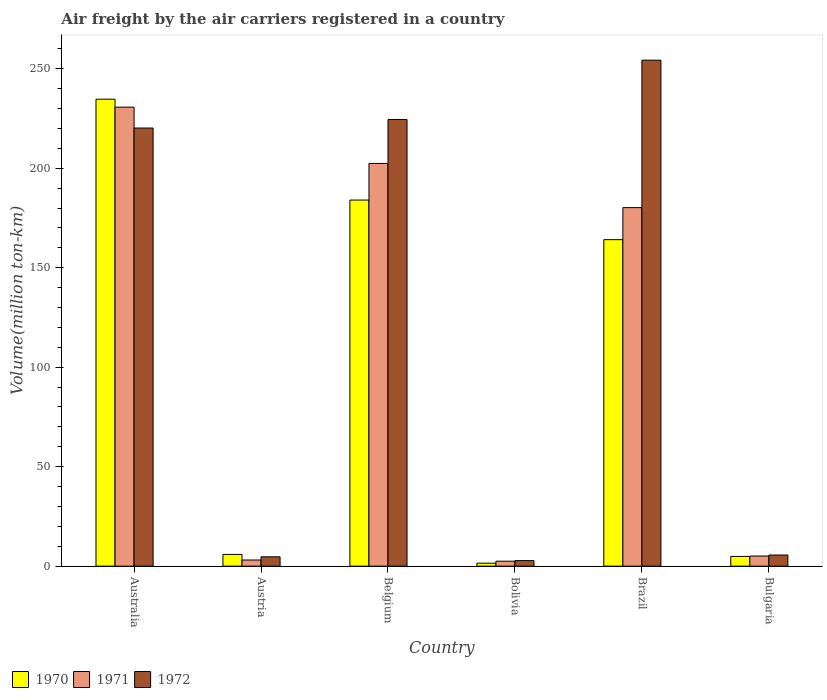How many different coloured bars are there?
Your answer should be compact. 3. How many groups of bars are there?
Provide a short and direct response. 6. Are the number of bars on each tick of the X-axis equal?
Your response must be concise. Yes. How many bars are there on the 4th tick from the right?
Offer a very short reply. 3. In how many cases, is the number of bars for a given country not equal to the number of legend labels?
Your response must be concise. 0. What is the volume of the air carriers in 1971 in Belgium?
Offer a very short reply. 202.4. Across all countries, what is the maximum volume of the air carriers in 1971?
Your answer should be very brief. 230.7. Across all countries, what is the minimum volume of the air carriers in 1970?
Provide a succinct answer. 1.5. In which country was the volume of the air carriers in 1970 maximum?
Your answer should be compact. Australia. What is the total volume of the air carriers in 1972 in the graph?
Offer a very short reply. 712.1. What is the difference between the volume of the air carriers in 1970 in Belgium and that in Bulgaria?
Provide a succinct answer. 179.1. What is the difference between the volume of the air carriers in 1970 in Austria and the volume of the air carriers in 1972 in Bulgaria?
Keep it short and to the point. 0.3. What is the average volume of the air carriers in 1971 per country?
Your answer should be very brief. 104. What is the difference between the volume of the air carriers of/in 1972 and volume of the air carriers of/in 1970 in Bolivia?
Offer a very short reply. 1.3. What is the ratio of the volume of the air carriers in 1971 in Bolivia to that in Brazil?
Provide a short and direct response. 0.01. Is the volume of the air carriers in 1971 in Belgium less than that in Bolivia?
Your answer should be very brief. No. What is the difference between the highest and the second highest volume of the air carriers in 1970?
Your response must be concise. -50.7. What is the difference between the highest and the lowest volume of the air carriers in 1970?
Ensure brevity in your answer.  233.2. Is it the case that in every country, the sum of the volume of the air carriers in 1970 and volume of the air carriers in 1972 is greater than the volume of the air carriers in 1971?
Provide a short and direct response. Yes. How many bars are there?
Your answer should be very brief. 18. Are all the bars in the graph horizontal?
Your answer should be very brief. No. How many countries are there in the graph?
Ensure brevity in your answer.  6. Are the values on the major ticks of Y-axis written in scientific E-notation?
Your response must be concise. No. Where does the legend appear in the graph?
Ensure brevity in your answer.  Bottom left. How many legend labels are there?
Your response must be concise. 3. How are the legend labels stacked?
Give a very brief answer. Horizontal. What is the title of the graph?
Provide a short and direct response. Air freight by the air carriers registered in a country. Does "1965" appear as one of the legend labels in the graph?
Ensure brevity in your answer.  No. What is the label or title of the Y-axis?
Offer a very short reply. Volume(million ton-km). What is the Volume(million ton-km) in 1970 in Australia?
Provide a short and direct response. 234.7. What is the Volume(million ton-km) of 1971 in Australia?
Offer a terse response. 230.7. What is the Volume(million ton-km) in 1972 in Australia?
Provide a short and direct response. 220.2. What is the Volume(million ton-km) of 1970 in Austria?
Give a very brief answer. 5.9. What is the Volume(million ton-km) of 1971 in Austria?
Your response must be concise. 3.1. What is the Volume(million ton-km) in 1972 in Austria?
Ensure brevity in your answer.  4.7. What is the Volume(million ton-km) in 1970 in Belgium?
Your answer should be compact. 184. What is the Volume(million ton-km) in 1971 in Belgium?
Your response must be concise. 202.4. What is the Volume(million ton-km) in 1972 in Belgium?
Provide a short and direct response. 224.5. What is the Volume(million ton-km) of 1971 in Bolivia?
Ensure brevity in your answer.  2.5. What is the Volume(million ton-km) of 1972 in Bolivia?
Provide a succinct answer. 2.8. What is the Volume(million ton-km) in 1970 in Brazil?
Ensure brevity in your answer.  164.1. What is the Volume(million ton-km) of 1971 in Brazil?
Offer a terse response. 180.2. What is the Volume(million ton-km) of 1972 in Brazil?
Offer a terse response. 254.3. What is the Volume(million ton-km) of 1970 in Bulgaria?
Offer a terse response. 4.9. What is the Volume(million ton-km) of 1971 in Bulgaria?
Your answer should be compact. 5.1. What is the Volume(million ton-km) in 1972 in Bulgaria?
Give a very brief answer. 5.6. Across all countries, what is the maximum Volume(million ton-km) in 1970?
Make the answer very short. 234.7. Across all countries, what is the maximum Volume(million ton-km) of 1971?
Your answer should be very brief. 230.7. Across all countries, what is the maximum Volume(million ton-km) of 1972?
Your answer should be very brief. 254.3. Across all countries, what is the minimum Volume(million ton-km) in 1972?
Make the answer very short. 2.8. What is the total Volume(million ton-km) in 1970 in the graph?
Offer a terse response. 595.1. What is the total Volume(million ton-km) in 1971 in the graph?
Your answer should be very brief. 624. What is the total Volume(million ton-km) of 1972 in the graph?
Provide a short and direct response. 712.1. What is the difference between the Volume(million ton-km) in 1970 in Australia and that in Austria?
Your answer should be very brief. 228.8. What is the difference between the Volume(million ton-km) of 1971 in Australia and that in Austria?
Provide a succinct answer. 227.6. What is the difference between the Volume(million ton-km) of 1972 in Australia and that in Austria?
Provide a short and direct response. 215.5. What is the difference between the Volume(million ton-km) of 1970 in Australia and that in Belgium?
Ensure brevity in your answer.  50.7. What is the difference between the Volume(million ton-km) in 1971 in Australia and that in Belgium?
Give a very brief answer. 28.3. What is the difference between the Volume(million ton-km) in 1970 in Australia and that in Bolivia?
Give a very brief answer. 233.2. What is the difference between the Volume(million ton-km) of 1971 in Australia and that in Bolivia?
Provide a short and direct response. 228.2. What is the difference between the Volume(million ton-km) of 1972 in Australia and that in Bolivia?
Provide a short and direct response. 217.4. What is the difference between the Volume(million ton-km) in 1970 in Australia and that in Brazil?
Keep it short and to the point. 70.6. What is the difference between the Volume(million ton-km) of 1971 in Australia and that in Brazil?
Your answer should be very brief. 50.5. What is the difference between the Volume(million ton-km) in 1972 in Australia and that in Brazil?
Provide a short and direct response. -34.1. What is the difference between the Volume(million ton-km) of 1970 in Australia and that in Bulgaria?
Offer a terse response. 229.8. What is the difference between the Volume(million ton-km) of 1971 in Australia and that in Bulgaria?
Provide a short and direct response. 225.6. What is the difference between the Volume(million ton-km) in 1972 in Australia and that in Bulgaria?
Make the answer very short. 214.6. What is the difference between the Volume(million ton-km) of 1970 in Austria and that in Belgium?
Your answer should be very brief. -178.1. What is the difference between the Volume(million ton-km) in 1971 in Austria and that in Belgium?
Offer a terse response. -199.3. What is the difference between the Volume(million ton-km) of 1972 in Austria and that in Belgium?
Offer a very short reply. -219.8. What is the difference between the Volume(million ton-km) in 1970 in Austria and that in Bolivia?
Keep it short and to the point. 4.4. What is the difference between the Volume(million ton-km) in 1971 in Austria and that in Bolivia?
Provide a succinct answer. 0.6. What is the difference between the Volume(million ton-km) of 1970 in Austria and that in Brazil?
Provide a succinct answer. -158.2. What is the difference between the Volume(million ton-km) of 1971 in Austria and that in Brazil?
Offer a very short reply. -177.1. What is the difference between the Volume(million ton-km) of 1972 in Austria and that in Brazil?
Your answer should be very brief. -249.6. What is the difference between the Volume(million ton-km) in 1971 in Austria and that in Bulgaria?
Provide a short and direct response. -2. What is the difference between the Volume(million ton-km) in 1970 in Belgium and that in Bolivia?
Your answer should be compact. 182.5. What is the difference between the Volume(million ton-km) of 1971 in Belgium and that in Bolivia?
Keep it short and to the point. 199.9. What is the difference between the Volume(million ton-km) of 1972 in Belgium and that in Bolivia?
Provide a succinct answer. 221.7. What is the difference between the Volume(million ton-km) in 1971 in Belgium and that in Brazil?
Your response must be concise. 22.2. What is the difference between the Volume(million ton-km) of 1972 in Belgium and that in Brazil?
Your response must be concise. -29.8. What is the difference between the Volume(million ton-km) of 1970 in Belgium and that in Bulgaria?
Keep it short and to the point. 179.1. What is the difference between the Volume(million ton-km) of 1971 in Belgium and that in Bulgaria?
Keep it short and to the point. 197.3. What is the difference between the Volume(million ton-km) of 1972 in Belgium and that in Bulgaria?
Your answer should be compact. 218.9. What is the difference between the Volume(million ton-km) in 1970 in Bolivia and that in Brazil?
Give a very brief answer. -162.6. What is the difference between the Volume(million ton-km) in 1971 in Bolivia and that in Brazil?
Offer a terse response. -177.7. What is the difference between the Volume(million ton-km) in 1972 in Bolivia and that in Brazil?
Your answer should be compact. -251.5. What is the difference between the Volume(million ton-km) in 1970 in Bolivia and that in Bulgaria?
Your response must be concise. -3.4. What is the difference between the Volume(million ton-km) in 1970 in Brazil and that in Bulgaria?
Offer a terse response. 159.2. What is the difference between the Volume(million ton-km) in 1971 in Brazil and that in Bulgaria?
Offer a very short reply. 175.1. What is the difference between the Volume(million ton-km) of 1972 in Brazil and that in Bulgaria?
Provide a succinct answer. 248.7. What is the difference between the Volume(million ton-km) of 1970 in Australia and the Volume(million ton-km) of 1971 in Austria?
Provide a succinct answer. 231.6. What is the difference between the Volume(million ton-km) of 1970 in Australia and the Volume(million ton-km) of 1972 in Austria?
Your answer should be very brief. 230. What is the difference between the Volume(million ton-km) of 1971 in Australia and the Volume(million ton-km) of 1972 in Austria?
Your answer should be compact. 226. What is the difference between the Volume(million ton-km) in 1970 in Australia and the Volume(million ton-km) in 1971 in Belgium?
Keep it short and to the point. 32.3. What is the difference between the Volume(million ton-km) of 1970 in Australia and the Volume(million ton-km) of 1971 in Bolivia?
Make the answer very short. 232.2. What is the difference between the Volume(million ton-km) of 1970 in Australia and the Volume(million ton-km) of 1972 in Bolivia?
Keep it short and to the point. 231.9. What is the difference between the Volume(million ton-km) in 1971 in Australia and the Volume(million ton-km) in 1972 in Bolivia?
Give a very brief answer. 227.9. What is the difference between the Volume(million ton-km) in 1970 in Australia and the Volume(million ton-km) in 1971 in Brazil?
Your answer should be compact. 54.5. What is the difference between the Volume(million ton-km) of 1970 in Australia and the Volume(million ton-km) of 1972 in Brazil?
Your answer should be very brief. -19.6. What is the difference between the Volume(million ton-km) of 1971 in Australia and the Volume(million ton-km) of 1972 in Brazil?
Keep it short and to the point. -23.6. What is the difference between the Volume(million ton-km) of 1970 in Australia and the Volume(million ton-km) of 1971 in Bulgaria?
Keep it short and to the point. 229.6. What is the difference between the Volume(million ton-km) in 1970 in Australia and the Volume(million ton-km) in 1972 in Bulgaria?
Keep it short and to the point. 229.1. What is the difference between the Volume(million ton-km) of 1971 in Australia and the Volume(million ton-km) of 1972 in Bulgaria?
Give a very brief answer. 225.1. What is the difference between the Volume(million ton-km) of 1970 in Austria and the Volume(million ton-km) of 1971 in Belgium?
Make the answer very short. -196.5. What is the difference between the Volume(million ton-km) of 1970 in Austria and the Volume(million ton-km) of 1972 in Belgium?
Make the answer very short. -218.6. What is the difference between the Volume(million ton-km) of 1971 in Austria and the Volume(million ton-km) of 1972 in Belgium?
Give a very brief answer. -221.4. What is the difference between the Volume(million ton-km) in 1970 in Austria and the Volume(million ton-km) in 1971 in Bolivia?
Your response must be concise. 3.4. What is the difference between the Volume(million ton-km) of 1970 in Austria and the Volume(million ton-km) of 1972 in Bolivia?
Provide a short and direct response. 3.1. What is the difference between the Volume(million ton-km) in 1970 in Austria and the Volume(million ton-km) in 1971 in Brazil?
Your answer should be compact. -174.3. What is the difference between the Volume(million ton-km) in 1970 in Austria and the Volume(million ton-km) in 1972 in Brazil?
Provide a succinct answer. -248.4. What is the difference between the Volume(million ton-km) of 1971 in Austria and the Volume(million ton-km) of 1972 in Brazil?
Give a very brief answer. -251.2. What is the difference between the Volume(million ton-km) in 1970 in Austria and the Volume(million ton-km) in 1972 in Bulgaria?
Offer a very short reply. 0.3. What is the difference between the Volume(million ton-km) in 1970 in Belgium and the Volume(million ton-km) in 1971 in Bolivia?
Make the answer very short. 181.5. What is the difference between the Volume(million ton-km) of 1970 in Belgium and the Volume(million ton-km) of 1972 in Bolivia?
Keep it short and to the point. 181.2. What is the difference between the Volume(million ton-km) of 1971 in Belgium and the Volume(million ton-km) of 1972 in Bolivia?
Your answer should be compact. 199.6. What is the difference between the Volume(million ton-km) in 1970 in Belgium and the Volume(million ton-km) in 1971 in Brazil?
Keep it short and to the point. 3.8. What is the difference between the Volume(million ton-km) of 1970 in Belgium and the Volume(million ton-km) of 1972 in Brazil?
Give a very brief answer. -70.3. What is the difference between the Volume(million ton-km) in 1971 in Belgium and the Volume(million ton-km) in 1972 in Brazil?
Ensure brevity in your answer.  -51.9. What is the difference between the Volume(million ton-km) of 1970 in Belgium and the Volume(million ton-km) of 1971 in Bulgaria?
Your answer should be compact. 178.9. What is the difference between the Volume(million ton-km) in 1970 in Belgium and the Volume(million ton-km) in 1972 in Bulgaria?
Keep it short and to the point. 178.4. What is the difference between the Volume(million ton-km) in 1971 in Belgium and the Volume(million ton-km) in 1972 in Bulgaria?
Provide a short and direct response. 196.8. What is the difference between the Volume(million ton-km) of 1970 in Bolivia and the Volume(million ton-km) of 1971 in Brazil?
Your answer should be compact. -178.7. What is the difference between the Volume(million ton-km) in 1970 in Bolivia and the Volume(million ton-km) in 1972 in Brazil?
Offer a terse response. -252.8. What is the difference between the Volume(million ton-km) in 1971 in Bolivia and the Volume(million ton-km) in 1972 in Brazil?
Provide a succinct answer. -251.8. What is the difference between the Volume(million ton-km) in 1970 in Bolivia and the Volume(million ton-km) in 1971 in Bulgaria?
Offer a terse response. -3.6. What is the difference between the Volume(million ton-km) in 1971 in Bolivia and the Volume(million ton-km) in 1972 in Bulgaria?
Make the answer very short. -3.1. What is the difference between the Volume(million ton-km) of 1970 in Brazil and the Volume(million ton-km) of 1971 in Bulgaria?
Give a very brief answer. 159. What is the difference between the Volume(million ton-km) in 1970 in Brazil and the Volume(million ton-km) in 1972 in Bulgaria?
Keep it short and to the point. 158.5. What is the difference between the Volume(million ton-km) of 1971 in Brazil and the Volume(million ton-km) of 1972 in Bulgaria?
Ensure brevity in your answer.  174.6. What is the average Volume(million ton-km) of 1970 per country?
Provide a succinct answer. 99.18. What is the average Volume(million ton-km) in 1971 per country?
Your response must be concise. 104. What is the average Volume(million ton-km) in 1972 per country?
Make the answer very short. 118.68. What is the difference between the Volume(million ton-km) in 1971 and Volume(million ton-km) in 1972 in Australia?
Your answer should be compact. 10.5. What is the difference between the Volume(million ton-km) of 1970 and Volume(million ton-km) of 1971 in Austria?
Give a very brief answer. 2.8. What is the difference between the Volume(million ton-km) of 1970 and Volume(million ton-km) of 1971 in Belgium?
Keep it short and to the point. -18.4. What is the difference between the Volume(million ton-km) of 1970 and Volume(million ton-km) of 1972 in Belgium?
Your answer should be very brief. -40.5. What is the difference between the Volume(million ton-km) of 1971 and Volume(million ton-km) of 1972 in Belgium?
Give a very brief answer. -22.1. What is the difference between the Volume(million ton-km) of 1971 and Volume(million ton-km) of 1972 in Bolivia?
Provide a succinct answer. -0.3. What is the difference between the Volume(million ton-km) in 1970 and Volume(million ton-km) in 1971 in Brazil?
Your answer should be very brief. -16.1. What is the difference between the Volume(million ton-km) in 1970 and Volume(million ton-km) in 1972 in Brazil?
Ensure brevity in your answer.  -90.2. What is the difference between the Volume(million ton-km) of 1971 and Volume(million ton-km) of 1972 in Brazil?
Offer a terse response. -74.1. What is the difference between the Volume(million ton-km) of 1970 and Volume(million ton-km) of 1972 in Bulgaria?
Your answer should be compact. -0.7. What is the difference between the Volume(million ton-km) of 1971 and Volume(million ton-km) of 1972 in Bulgaria?
Make the answer very short. -0.5. What is the ratio of the Volume(million ton-km) of 1970 in Australia to that in Austria?
Give a very brief answer. 39.78. What is the ratio of the Volume(million ton-km) of 1971 in Australia to that in Austria?
Provide a succinct answer. 74.42. What is the ratio of the Volume(million ton-km) of 1972 in Australia to that in Austria?
Offer a terse response. 46.85. What is the ratio of the Volume(million ton-km) in 1970 in Australia to that in Belgium?
Provide a short and direct response. 1.28. What is the ratio of the Volume(million ton-km) of 1971 in Australia to that in Belgium?
Provide a short and direct response. 1.14. What is the ratio of the Volume(million ton-km) of 1972 in Australia to that in Belgium?
Make the answer very short. 0.98. What is the ratio of the Volume(million ton-km) of 1970 in Australia to that in Bolivia?
Your answer should be compact. 156.47. What is the ratio of the Volume(million ton-km) in 1971 in Australia to that in Bolivia?
Provide a short and direct response. 92.28. What is the ratio of the Volume(million ton-km) in 1972 in Australia to that in Bolivia?
Offer a very short reply. 78.64. What is the ratio of the Volume(million ton-km) of 1970 in Australia to that in Brazil?
Give a very brief answer. 1.43. What is the ratio of the Volume(million ton-km) of 1971 in Australia to that in Brazil?
Make the answer very short. 1.28. What is the ratio of the Volume(million ton-km) of 1972 in Australia to that in Brazil?
Your response must be concise. 0.87. What is the ratio of the Volume(million ton-km) in 1970 in Australia to that in Bulgaria?
Your answer should be very brief. 47.9. What is the ratio of the Volume(million ton-km) in 1971 in Australia to that in Bulgaria?
Make the answer very short. 45.24. What is the ratio of the Volume(million ton-km) of 1972 in Australia to that in Bulgaria?
Your answer should be compact. 39.32. What is the ratio of the Volume(million ton-km) of 1970 in Austria to that in Belgium?
Your answer should be very brief. 0.03. What is the ratio of the Volume(million ton-km) of 1971 in Austria to that in Belgium?
Provide a short and direct response. 0.02. What is the ratio of the Volume(million ton-km) in 1972 in Austria to that in Belgium?
Give a very brief answer. 0.02. What is the ratio of the Volume(million ton-km) of 1970 in Austria to that in Bolivia?
Your answer should be very brief. 3.93. What is the ratio of the Volume(million ton-km) of 1971 in Austria to that in Bolivia?
Give a very brief answer. 1.24. What is the ratio of the Volume(million ton-km) of 1972 in Austria to that in Bolivia?
Offer a terse response. 1.68. What is the ratio of the Volume(million ton-km) of 1970 in Austria to that in Brazil?
Offer a terse response. 0.04. What is the ratio of the Volume(million ton-km) in 1971 in Austria to that in Brazil?
Make the answer very short. 0.02. What is the ratio of the Volume(million ton-km) of 1972 in Austria to that in Brazil?
Your answer should be compact. 0.02. What is the ratio of the Volume(million ton-km) of 1970 in Austria to that in Bulgaria?
Your answer should be compact. 1.2. What is the ratio of the Volume(million ton-km) of 1971 in Austria to that in Bulgaria?
Offer a terse response. 0.61. What is the ratio of the Volume(million ton-km) in 1972 in Austria to that in Bulgaria?
Offer a terse response. 0.84. What is the ratio of the Volume(million ton-km) in 1970 in Belgium to that in Bolivia?
Provide a short and direct response. 122.67. What is the ratio of the Volume(million ton-km) of 1971 in Belgium to that in Bolivia?
Give a very brief answer. 80.96. What is the ratio of the Volume(million ton-km) in 1972 in Belgium to that in Bolivia?
Your response must be concise. 80.18. What is the ratio of the Volume(million ton-km) of 1970 in Belgium to that in Brazil?
Ensure brevity in your answer.  1.12. What is the ratio of the Volume(million ton-km) of 1971 in Belgium to that in Brazil?
Your answer should be very brief. 1.12. What is the ratio of the Volume(million ton-km) of 1972 in Belgium to that in Brazil?
Your answer should be very brief. 0.88. What is the ratio of the Volume(million ton-km) in 1970 in Belgium to that in Bulgaria?
Your answer should be compact. 37.55. What is the ratio of the Volume(million ton-km) in 1971 in Belgium to that in Bulgaria?
Make the answer very short. 39.69. What is the ratio of the Volume(million ton-km) in 1972 in Belgium to that in Bulgaria?
Make the answer very short. 40.09. What is the ratio of the Volume(million ton-km) of 1970 in Bolivia to that in Brazil?
Your answer should be very brief. 0.01. What is the ratio of the Volume(million ton-km) in 1971 in Bolivia to that in Brazil?
Provide a succinct answer. 0.01. What is the ratio of the Volume(million ton-km) of 1972 in Bolivia to that in Brazil?
Offer a terse response. 0.01. What is the ratio of the Volume(million ton-km) of 1970 in Bolivia to that in Bulgaria?
Your answer should be very brief. 0.31. What is the ratio of the Volume(million ton-km) in 1971 in Bolivia to that in Bulgaria?
Provide a succinct answer. 0.49. What is the ratio of the Volume(million ton-km) of 1970 in Brazil to that in Bulgaria?
Offer a terse response. 33.49. What is the ratio of the Volume(million ton-km) of 1971 in Brazil to that in Bulgaria?
Your answer should be compact. 35.33. What is the ratio of the Volume(million ton-km) in 1972 in Brazil to that in Bulgaria?
Offer a very short reply. 45.41. What is the difference between the highest and the second highest Volume(million ton-km) in 1970?
Provide a succinct answer. 50.7. What is the difference between the highest and the second highest Volume(million ton-km) in 1971?
Your response must be concise. 28.3. What is the difference between the highest and the second highest Volume(million ton-km) in 1972?
Make the answer very short. 29.8. What is the difference between the highest and the lowest Volume(million ton-km) in 1970?
Provide a short and direct response. 233.2. What is the difference between the highest and the lowest Volume(million ton-km) of 1971?
Offer a terse response. 228.2. What is the difference between the highest and the lowest Volume(million ton-km) of 1972?
Make the answer very short. 251.5. 